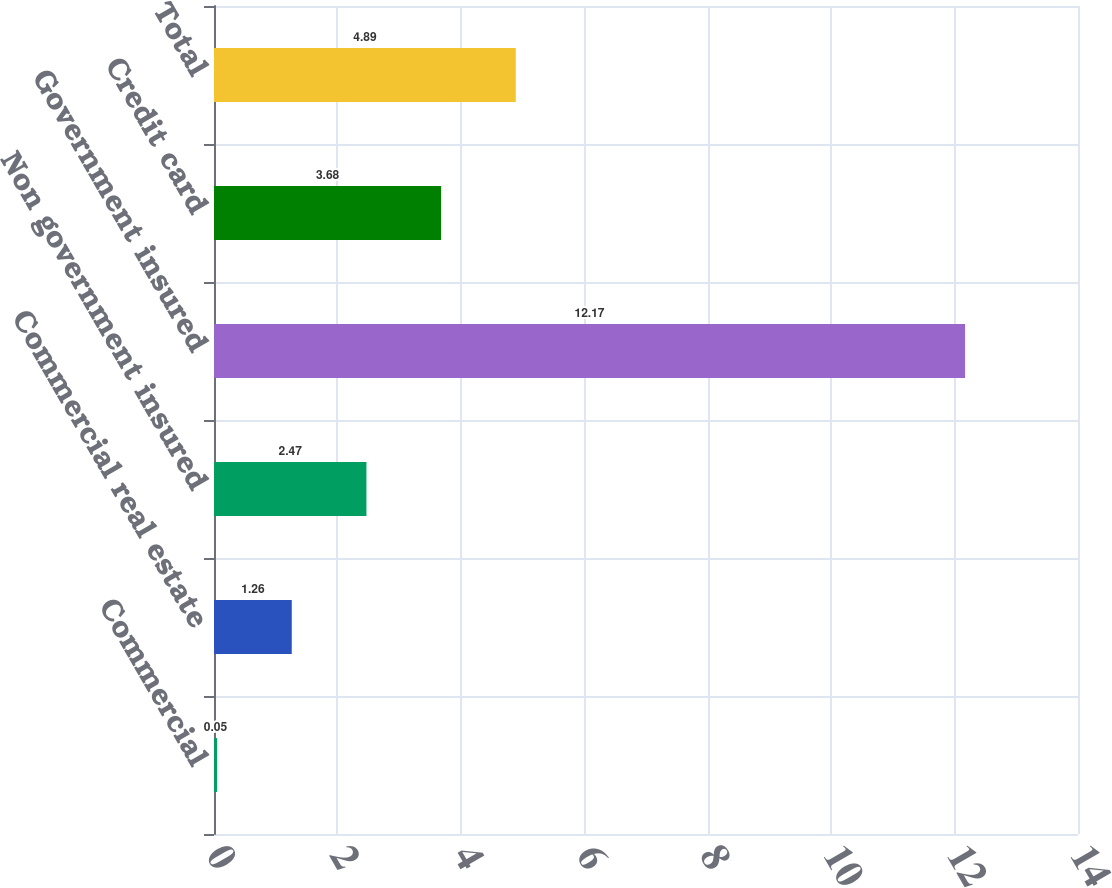Convert chart. <chart><loc_0><loc_0><loc_500><loc_500><bar_chart><fcel>Commercial<fcel>Commercial real estate<fcel>Non government insured<fcel>Government insured<fcel>Credit card<fcel>Total<nl><fcel>0.05<fcel>1.26<fcel>2.47<fcel>12.17<fcel>3.68<fcel>4.89<nl></chart> 